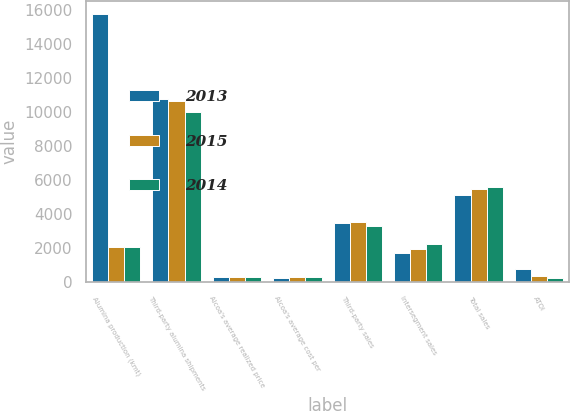<chart> <loc_0><loc_0><loc_500><loc_500><stacked_bar_chart><ecel><fcel>Alumina production (kmt)<fcel>Third-party alumina shipments<fcel>Alcoa's average realized price<fcel>Alcoa's average cost per<fcel>Third-party sales<fcel>Intersegment sales<fcel>Total sales<fcel>ATOI<nl><fcel>2013<fcel>15720<fcel>10755<fcel>317<fcel>237<fcel>3455<fcel>1687<fcel>5142<fcel>746<nl><fcel>2015<fcel>2088<fcel>10652<fcel>324<fcel>282<fcel>3509<fcel>1941<fcel>5450<fcel>370<nl><fcel>2014<fcel>2088<fcel>9966<fcel>328<fcel>295<fcel>3326<fcel>2235<fcel>5561<fcel>259<nl></chart> 